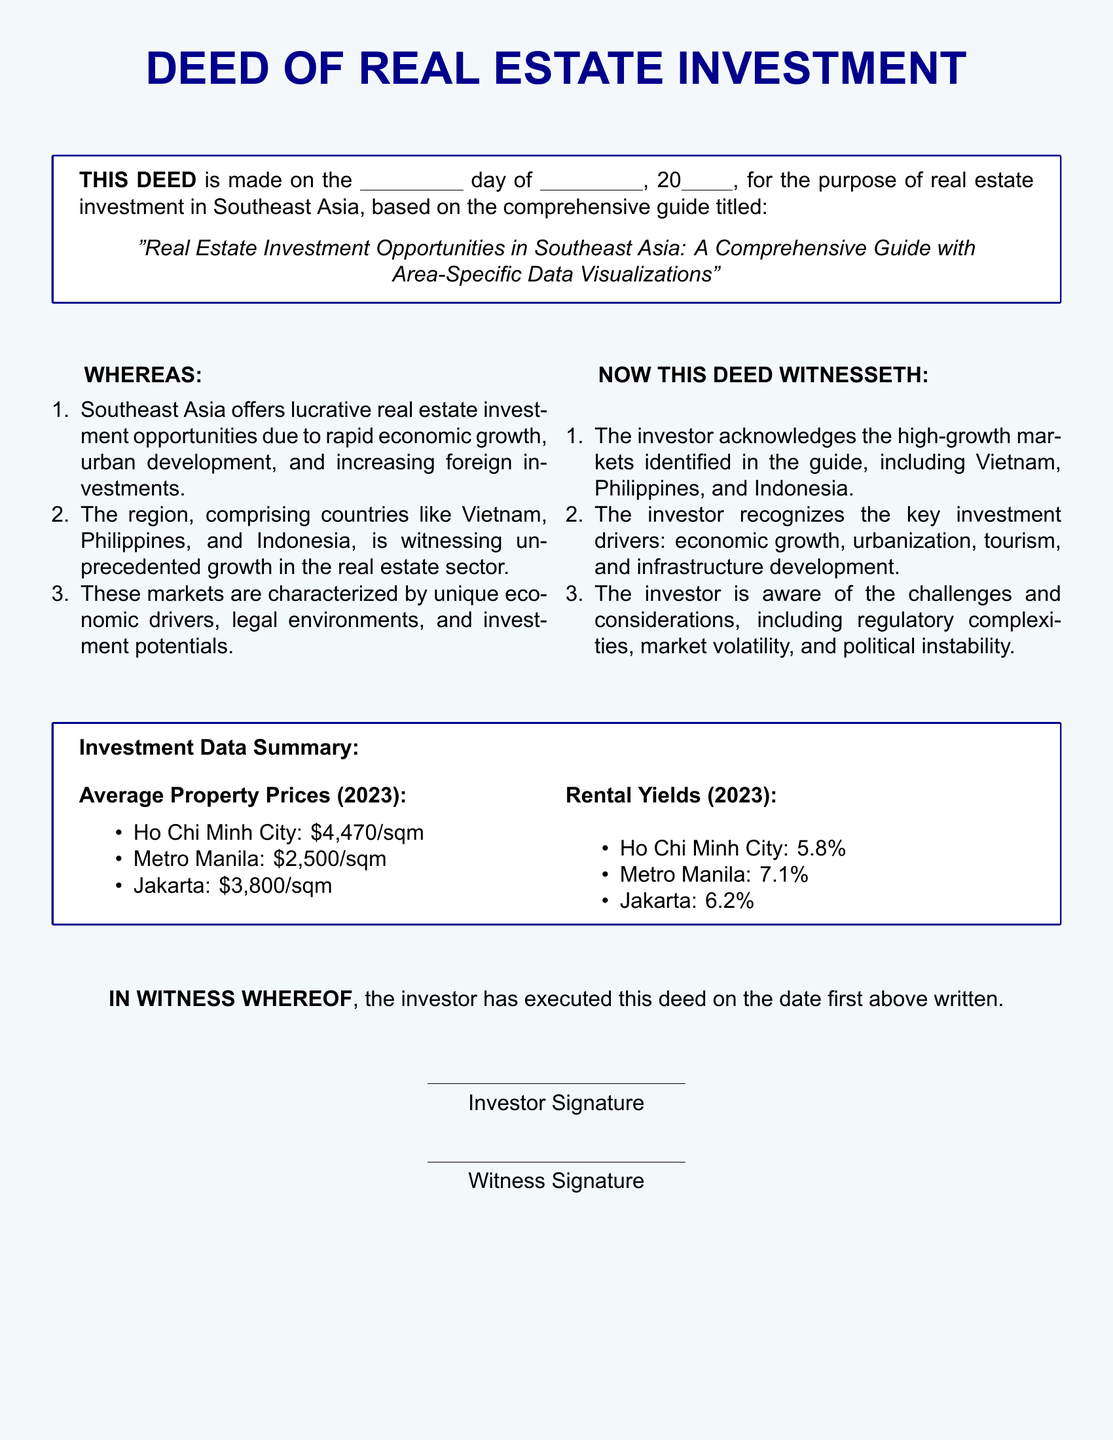What is this document titled? The title of the document is stated clearly at the beginning.
Answer: Real Estate Investment Opportunities in Southeast Asia: A Comprehensive Guide with Area-Specific Data Visualizations What is the average property price in Ho Chi Minh City? The document provides specific average property prices for different cities.
Answer: $4,470/sqm What is the rental yield in Metro Manila? The rental yields for different cities are listed in the Investment Data Summary section.
Answer: 7.1% Which three countries are highlighted for real estate investment? The WHEREAS section mentions the countries included.
Answer: Vietnam, Philippines, Indonesia What are the key investment drivers listed in the deed? The key investment drivers are mentioned in the NOW THIS DEED WITNESSETH section.
Answer: Economic growth, urbanization, tourism, infrastructure development What challenges are acknowledged in this deed? The challenges are stated in the NOW THIS DEED WITNESSETH section.
Answer: Regulatory complexities, market volatility, political instability On what date was this deed executed? The date is a blank space intended to be filled by the investor.
Answer: \underline{\hspace{2cm}} day of \underline{\hspace{2cm}}, 20\underline{\hspace{1cm}} Who needs to sign the document? The IN WITNESS WHEREOF section indicates those who need to sign.
Answer: Investor, Witness 